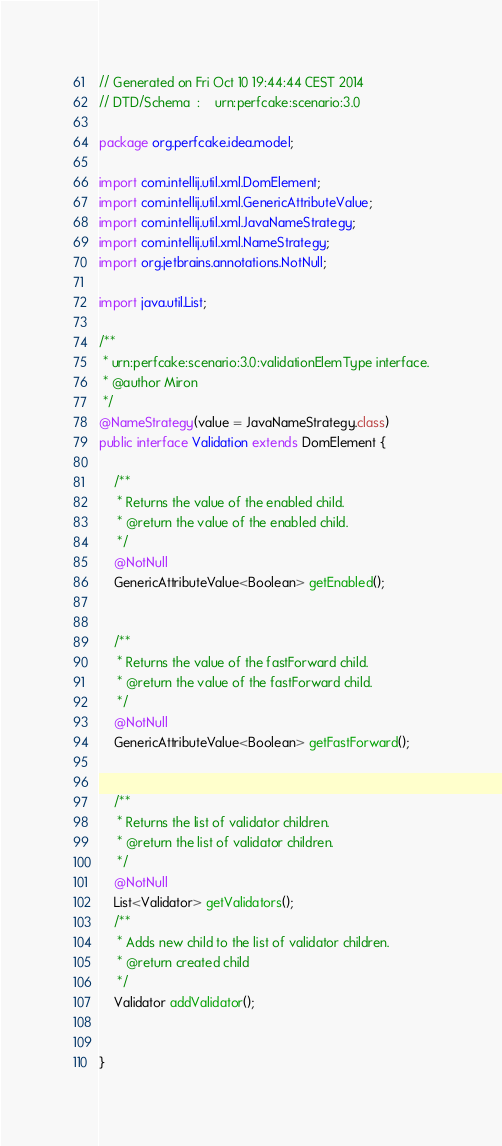<code> <loc_0><loc_0><loc_500><loc_500><_Java_>// Generated on Fri Oct 10 19:44:44 CEST 2014
// DTD/Schema  :    urn:perfcake:scenario:3.0

package org.perfcake.idea.model;

import com.intellij.util.xml.DomElement;
import com.intellij.util.xml.GenericAttributeValue;
import com.intellij.util.xml.JavaNameStrategy;
import com.intellij.util.xml.NameStrategy;
import org.jetbrains.annotations.NotNull;

import java.util.List;

/**
 * urn:perfcake:scenario:3.0:validationElemType interface.
 * @author Miron
 */
@NameStrategy(value = JavaNameStrategy.class)
public interface Validation extends DomElement {

	/**
	 * Returns the value of the enabled child.
	 * @return the value of the enabled child.
	 */
	@NotNull
	GenericAttributeValue<Boolean> getEnabled();


	/**
	 * Returns the value of the fastForward child.
	 * @return the value of the fastForward child.
	 */
	@NotNull
	GenericAttributeValue<Boolean> getFastForward();


	/**
	 * Returns the list of validator children.
	 * @return the list of validator children.
	 */
	@NotNull
	List<Validator> getValidators();
	/**
	 * Adds new child to the list of validator children.
	 * @return created child
	 */
	Validator addValidator();


}
</code> 